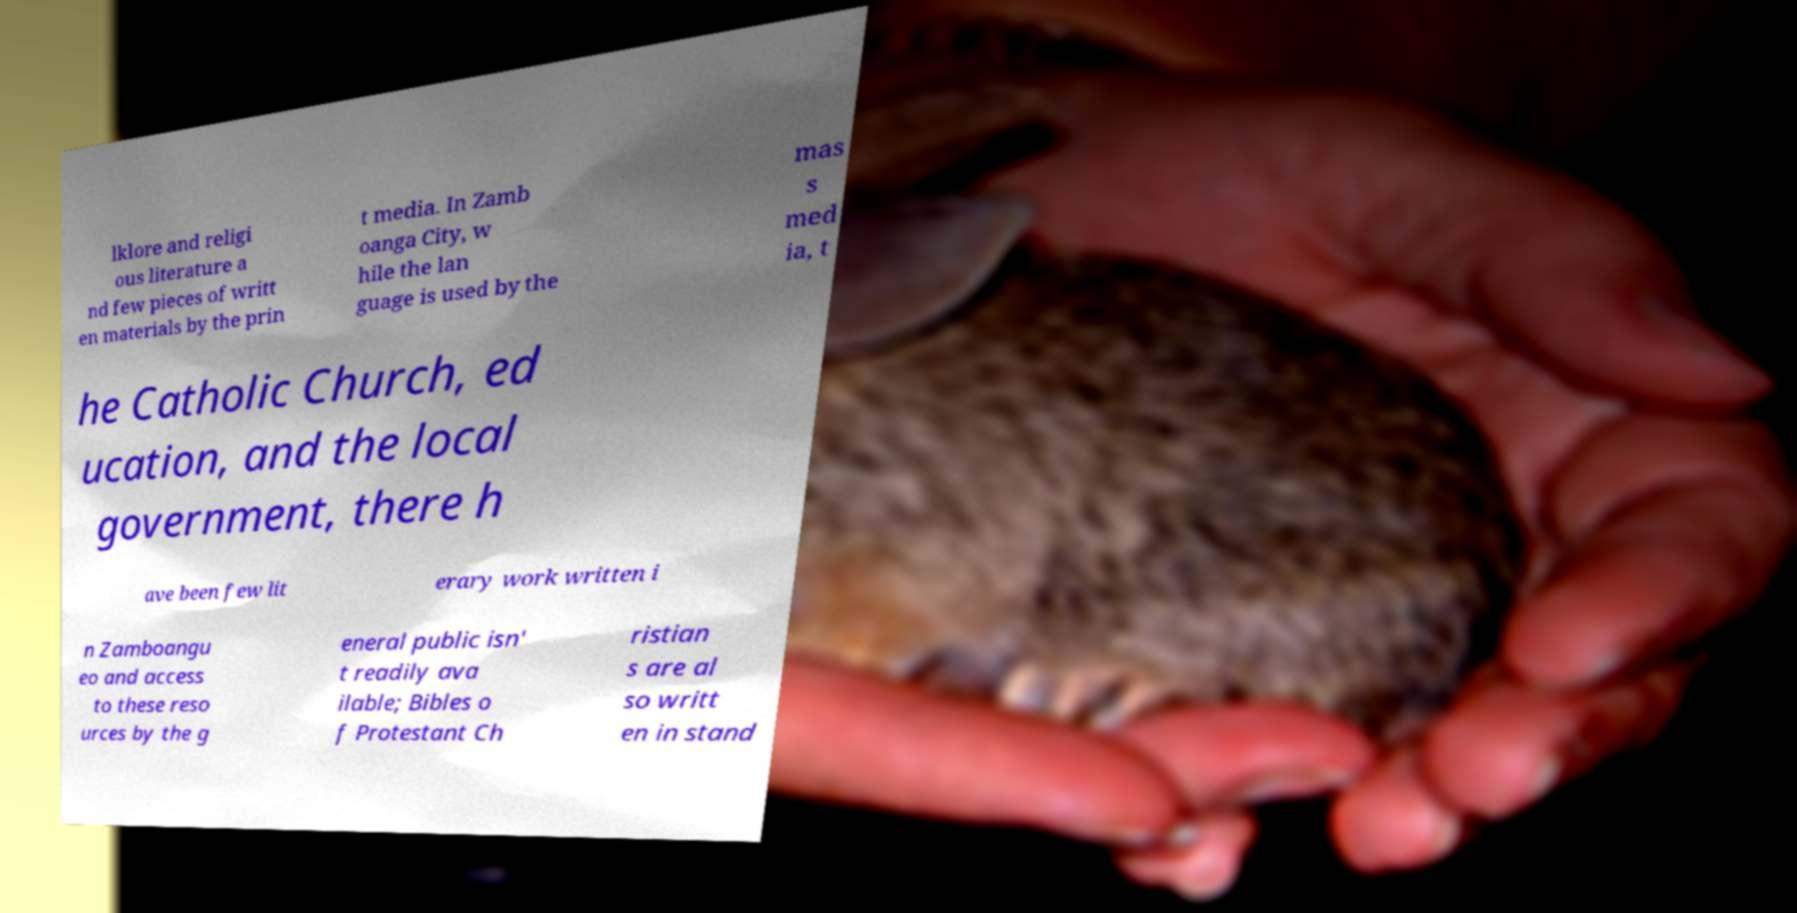Can you accurately transcribe the text from the provided image for me? lklore and religi ous literature a nd few pieces of writt en materials by the prin t media. In Zamb oanga City, w hile the lan guage is used by the mas s med ia, t he Catholic Church, ed ucation, and the local government, there h ave been few lit erary work written i n Zamboangu eo and access to these reso urces by the g eneral public isn' t readily ava ilable; Bibles o f Protestant Ch ristian s are al so writt en in stand 